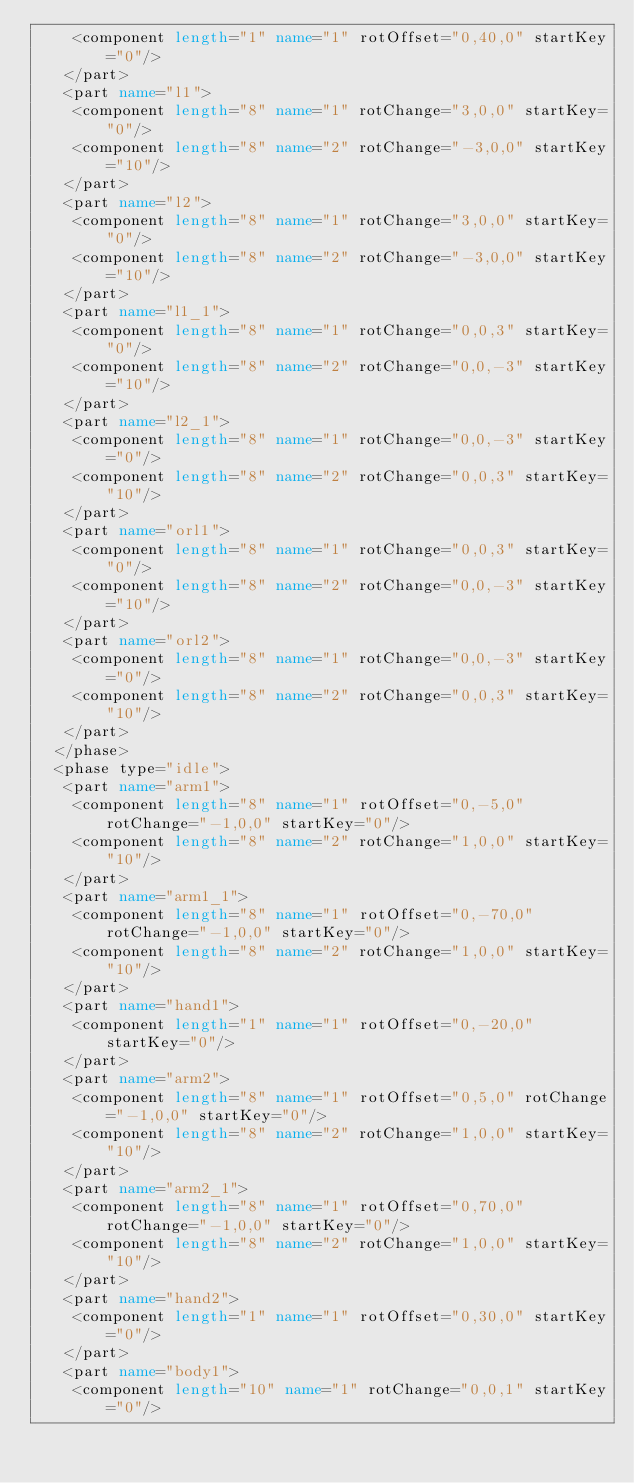<code> <loc_0><loc_0><loc_500><loc_500><_XML_>    <component length="1" name="1" rotOffset="0,40,0" startKey="0"/>
   </part>
   <part name="l1">
    <component length="8" name="1" rotChange="3,0,0" startKey="0"/>
    <component length="8" name="2" rotChange="-3,0,0" startKey="10"/>
   </part>
   <part name="l2">
    <component length="8" name="1" rotChange="3,0,0" startKey="0"/>
    <component length="8" name="2" rotChange="-3,0,0" startKey="10"/>
   </part>
   <part name="l1_1">
    <component length="8" name="1" rotChange="0,0,3" startKey="0"/>
    <component length="8" name="2" rotChange="0,0,-3" startKey="10"/>
   </part>
   <part name="l2_1">
    <component length="8" name="1" rotChange="0,0,-3" startKey="0"/>
    <component length="8" name="2" rotChange="0,0,3" startKey="10"/>
   </part>
   <part name="orl1">
    <component length="8" name="1" rotChange="0,0,3" startKey="0"/>
    <component length="8" name="2" rotChange="0,0,-3" startKey="10"/>
   </part>
   <part name="orl2">
    <component length="8" name="1" rotChange="0,0,-3" startKey="0"/>
    <component length="8" name="2" rotChange="0,0,3" startKey="10"/>
   </part>
  </phase>
  <phase type="idle">
   <part name="arm1">
    <component length="8" name="1" rotOffset="0,-5,0" rotChange="-1,0,0" startKey="0"/>
    <component length="8" name="2" rotChange="1,0,0" startKey="10"/>
   </part>
   <part name="arm1_1">
    <component length="8" name="1" rotOffset="0,-70,0" rotChange="-1,0,0" startKey="0"/>
    <component length="8" name="2" rotChange="1,0,0" startKey="10"/>
   </part>
   <part name="hand1">
    <component length="1" name="1" rotOffset="0,-20,0" startKey="0"/>
   </part>
   <part name="arm2">
    <component length="8" name="1" rotOffset="0,5,0" rotChange="-1,0,0" startKey="0"/>
    <component length="8" name="2" rotChange="1,0,0" startKey="10"/>
   </part>
   <part name="arm2_1">
    <component length="8" name="1" rotOffset="0,70,0" rotChange="-1,0,0" startKey="0"/>
    <component length="8" name="2" rotChange="1,0,0" startKey="10"/>
   </part>
   <part name="hand2">
    <component length="1" name="1" rotOffset="0,30,0" startKey="0"/>
   </part>
   <part name="body1">
    <component length="10" name="1" rotChange="0,0,1" startKey="0"/></code> 